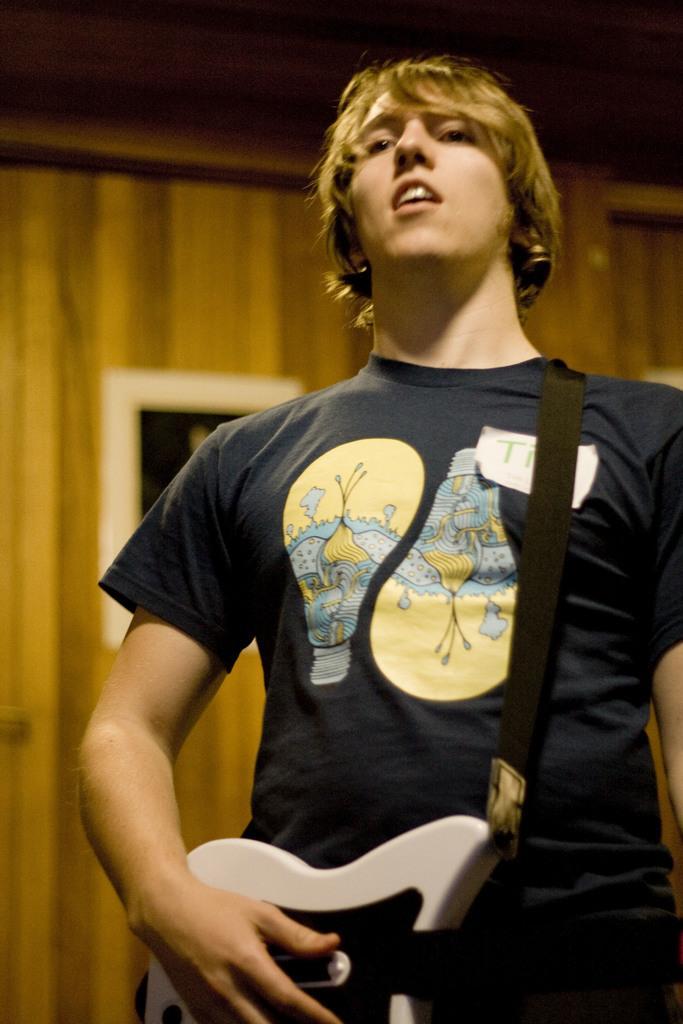In one or two sentences, can you explain what this image depicts? In this image, There is a boy standing and holding a music instrument which is in white color and in the background there is a yellow color wall. 